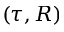<formula> <loc_0><loc_0><loc_500><loc_500>( \tau , R )</formula> 